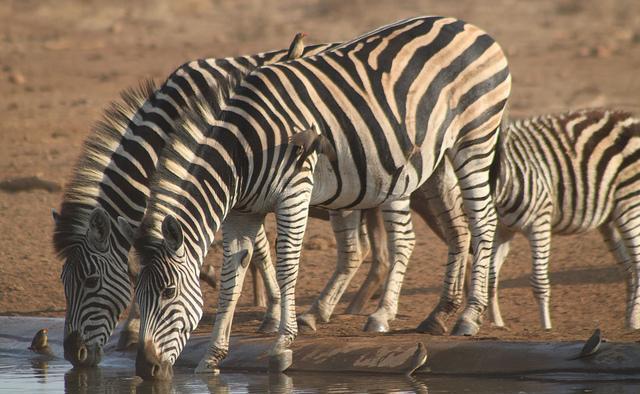How many zebra are  standing?
Give a very brief answer. 3. How many zebras?
Give a very brief answer. 3. How many zebras are drinking?
Give a very brief answer. 2. How many zebras can be seen?
Give a very brief answer. 3. How many bananas do they have?
Give a very brief answer. 0. 